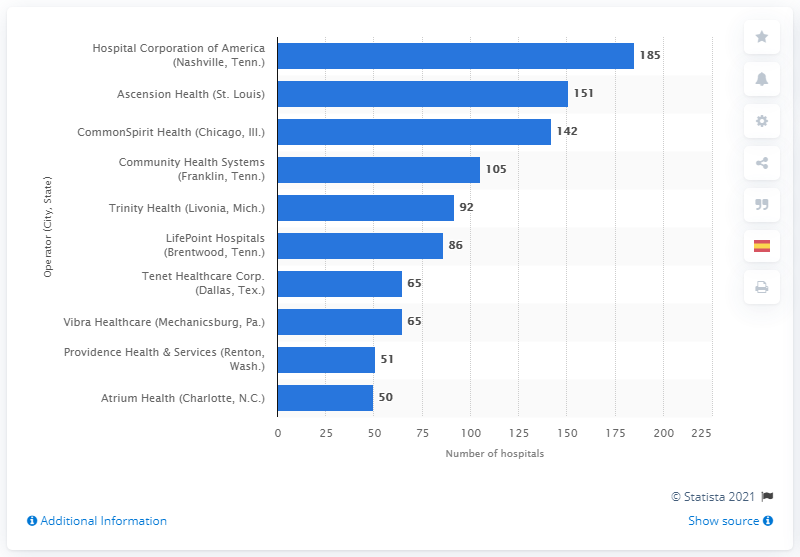Point out several critical features in this image. Ascension Health and Hospital Corporation of America have a total of 336 hospitals. According to the latest data from 2019, Hospital Corporation of America (HCA), located in Nashville, Tennessee, is the top U.S. health system in terms of the number of hospitals it operates. The Hospital Corporation of America has 185 hospitals. 